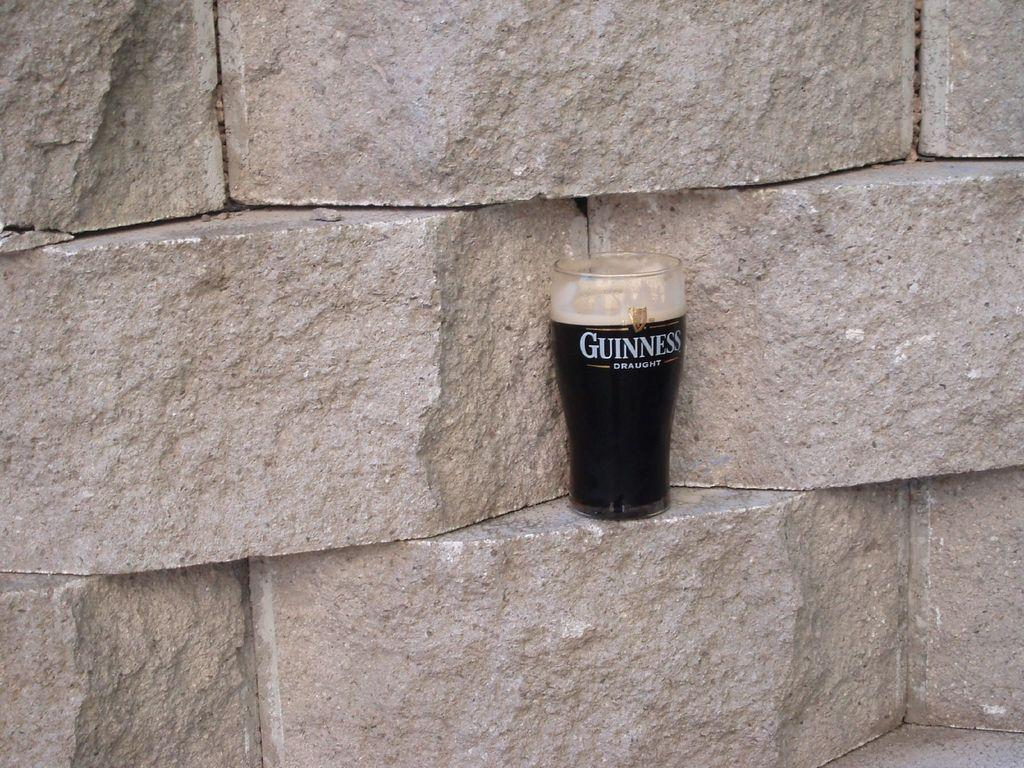<image>
Summarize the visual content of the image. Tall glass of beer that says Guinness on top of a brick. 